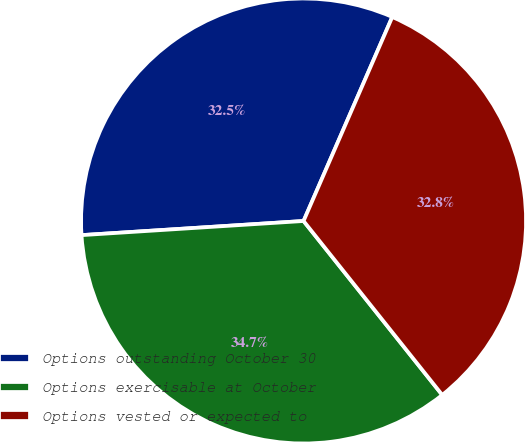Convert chart. <chart><loc_0><loc_0><loc_500><loc_500><pie_chart><fcel>Options outstanding October 30<fcel>Options exercisable at October<fcel>Options vested or expected to<nl><fcel>32.54%<fcel>34.7%<fcel>32.76%<nl></chart> 